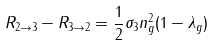<formula> <loc_0><loc_0><loc_500><loc_500>R _ { 2 \rightarrow 3 } - R _ { 3 \rightarrow 2 } = \frac { 1 } { 2 } \sigma _ { 3 } n _ { g } ^ { 2 } ( 1 - \lambda _ { g } )</formula> 